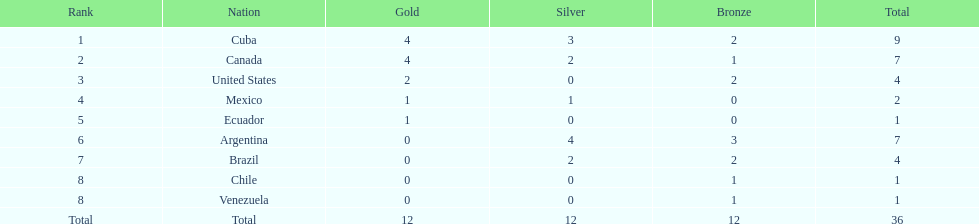How many total medals did brazil received? 4. 